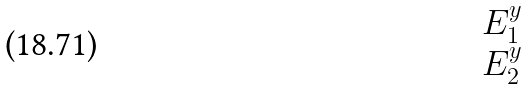Convert formula to latex. <formula><loc_0><loc_0><loc_500><loc_500>\begin{matrix} E _ { 1 } ^ { y } \\ E _ { 2 } ^ { y } \end{matrix}</formula> 